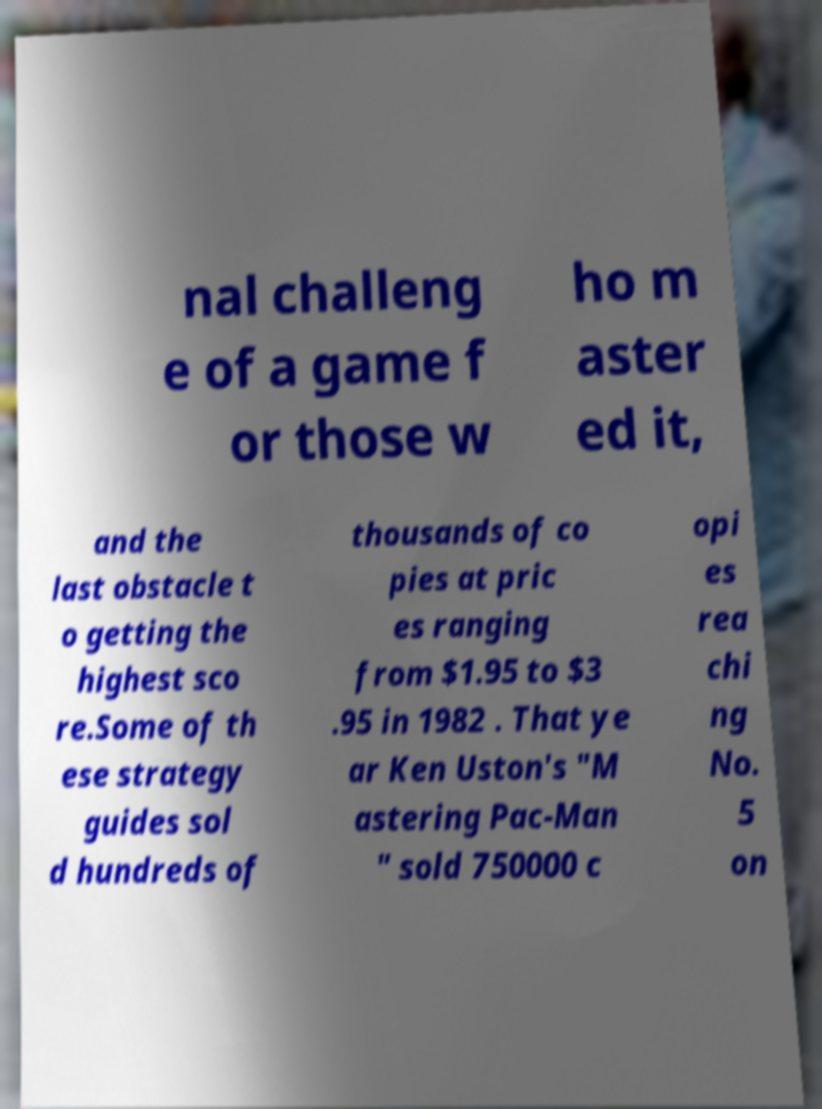Can you read and provide the text displayed in the image?This photo seems to have some interesting text. Can you extract and type it out for me? nal challeng e of a game f or those w ho m aster ed it, and the last obstacle t o getting the highest sco re.Some of th ese strategy guides sol d hundreds of thousands of co pies at pric es ranging from $1.95 to $3 .95 in 1982 . That ye ar Ken Uston's "M astering Pac-Man " sold 750000 c opi es rea chi ng No. 5 on 